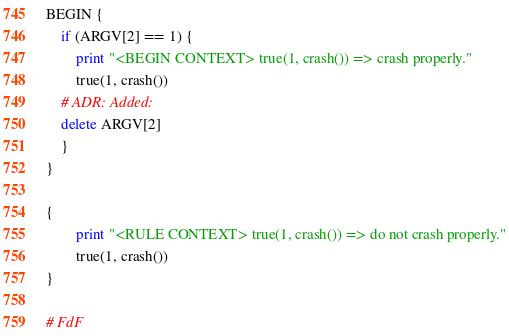Convert code to text. <code><loc_0><loc_0><loc_500><loc_500><_Awk_>
BEGIN {
    if (ARGV[2] == 1) {
        print "<BEGIN CONTEXT> true(1, crash()) => crash properly."
        true(1, crash())
	# ADR: Added:
	delete ARGV[2]
    }
}

{
        print "<RULE CONTEXT> true(1, crash()) => do not crash properly."
        true(1, crash())
}

# FdF
</code> 